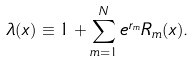<formula> <loc_0><loc_0><loc_500><loc_500>\lambda ( x ) \equiv 1 + \sum _ { m = 1 } ^ { N } e ^ { r _ { m } } R _ { m } ( x ) .</formula> 